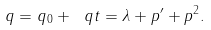<formula> <loc_0><loc_0><loc_500><loc_500>q = q _ { 0 } + \ q t = \lambda + p ^ { \prime } + p ^ { 2 } .</formula> 